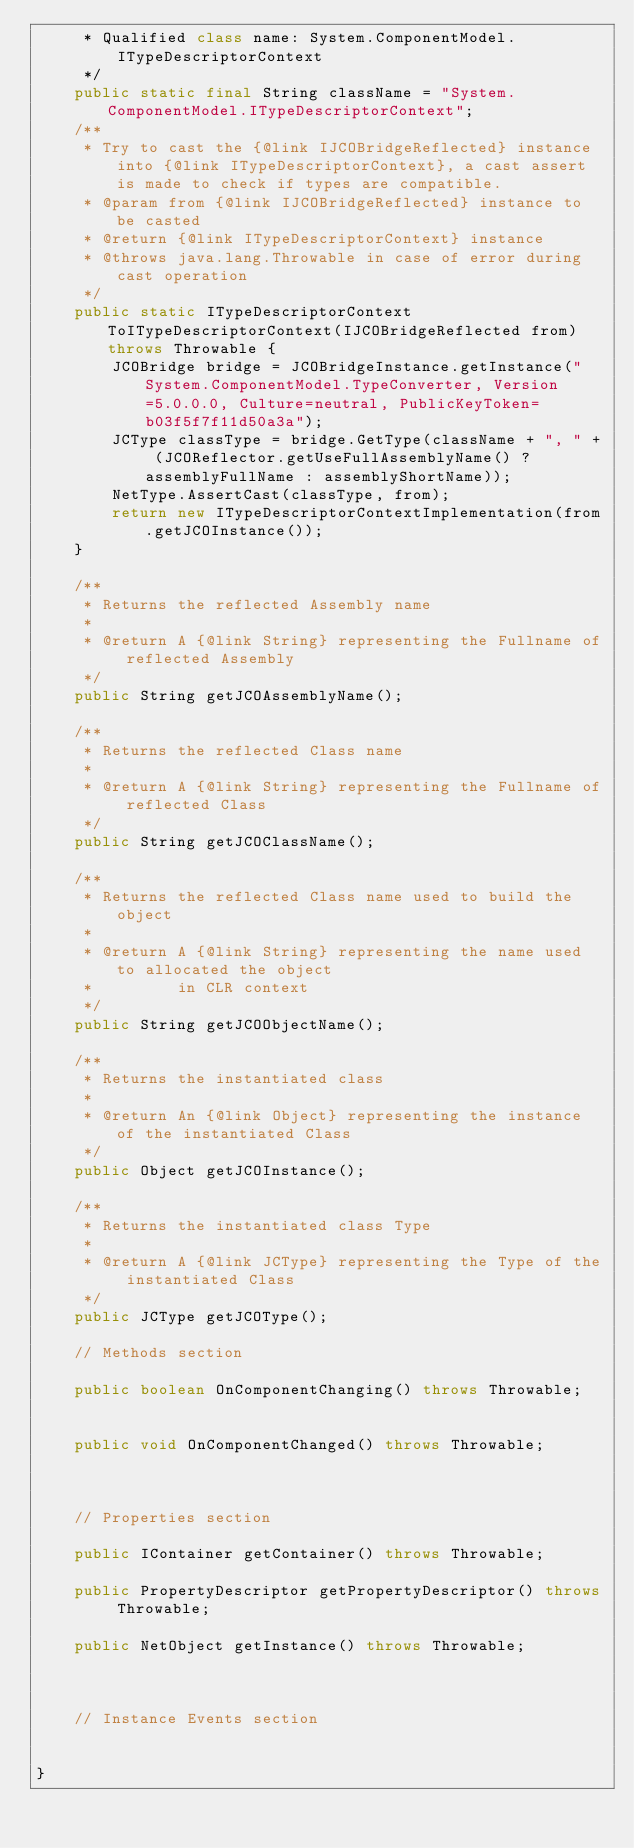Convert code to text. <code><loc_0><loc_0><loc_500><loc_500><_Java_>     * Qualified class name: System.ComponentModel.ITypeDescriptorContext
     */
    public static final String className = "System.ComponentModel.ITypeDescriptorContext";
    /**
     * Try to cast the {@link IJCOBridgeReflected} instance into {@link ITypeDescriptorContext}, a cast assert is made to check if types are compatible.
     * @param from {@link IJCOBridgeReflected} instance to be casted
     * @return {@link ITypeDescriptorContext} instance
     * @throws java.lang.Throwable in case of error during cast operation
     */
    public static ITypeDescriptorContext ToITypeDescriptorContext(IJCOBridgeReflected from) throws Throwable {
        JCOBridge bridge = JCOBridgeInstance.getInstance("System.ComponentModel.TypeConverter, Version=5.0.0.0, Culture=neutral, PublicKeyToken=b03f5f7f11d50a3a");
        JCType classType = bridge.GetType(className + ", " + (JCOReflector.getUseFullAssemblyName() ? assemblyFullName : assemblyShortName));
        NetType.AssertCast(classType, from);
        return new ITypeDescriptorContextImplementation(from.getJCOInstance());
    }

    /**
     * Returns the reflected Assembly name
     * 
     * @return A {@link String} representing the Fullname of reflected Assembly
     */
    public String getJCOAssemblyName();

    /**
     * Returns the reflected Class name
     * 
     * @return A {@link String} representing the Fullname of reflected Class
     */
    public String getJCOClassName();

    /**
     * Returns the reflected Class name used to build the object
     * 
     * @return A {@link String} representing the name used to allocated the object
     *         in CLR context
     */
    public String getJCOObjectName();

    /**
     * Returns the instantiated class
     * 
     * @return An {@link Object} representing the instance of the instantiated Class
     */
    public Object getJCOInstance();

    /**
     * Returns the instantiated class Type
     * 
     * @return A {@link JCType} representing the Type of the instantiated Class
     */
    public JCType getJCOType();

    // Methods section
    
    public boolean OnComponentChanging() throws Throwable;


    public void OnComponentChanged() throws Throwable;


    
    // Properties section
    
    public IContainer getContainer() throws Throwable;

    public PropertyDescriptor getPropertyDescriptor() throws Throwable;

    public NetObject getInstance() throws Throwable;



    // Instance Events section
    

}</code> 